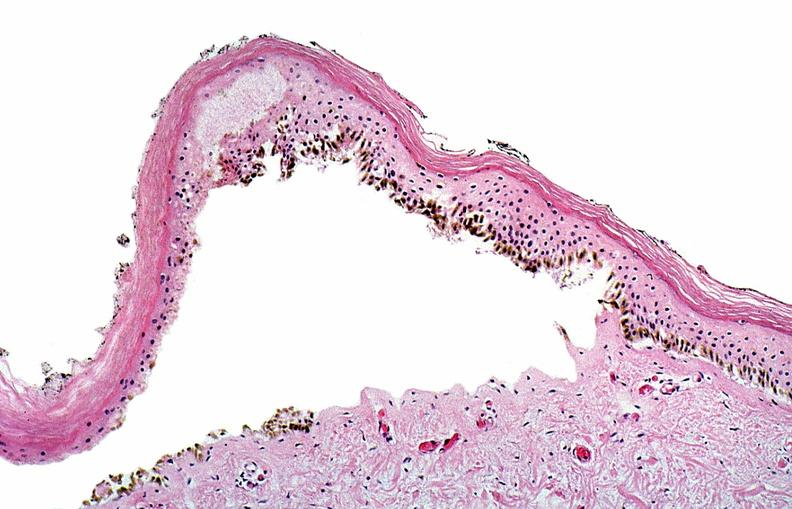where is this?
Answer the question using a single word or phrase. Skin 